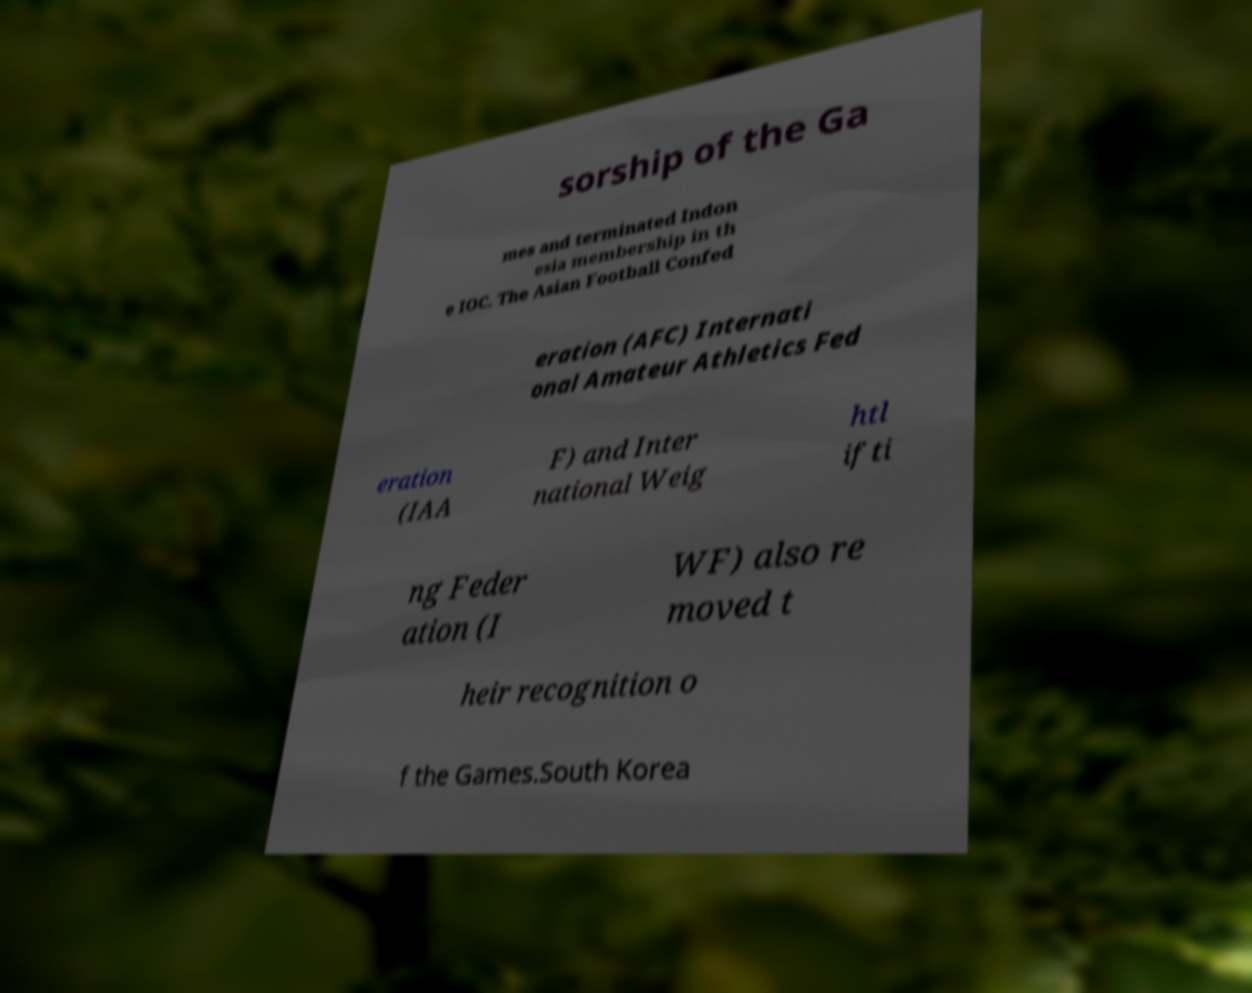What messages or text are displayed in this image? I need them in a readable, typed format. sorship of the Ga mes and terminated Indon esia membership in th e IOC. The Asian Football Confed eration (AFC) Internati onal Amateur Athletics Fed eration (IAA F) and Inter national Weig htl ifti ng Feder ation (I WF) also re moved t heir recognition o f the Games.South Korea 